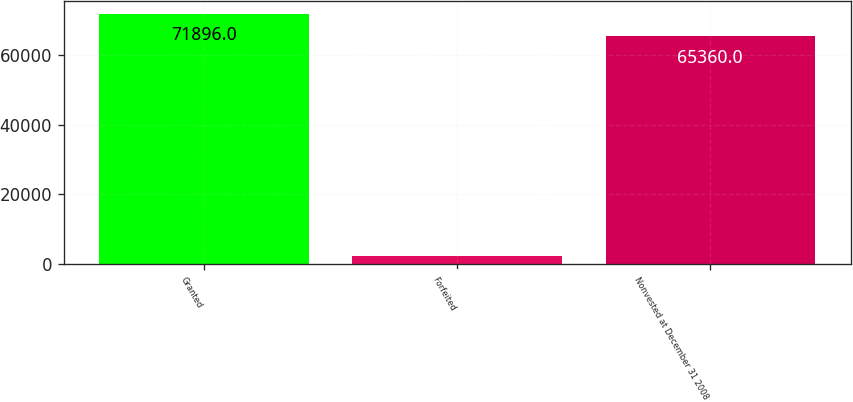Convert chart. <chart><loc_0><loc_0><loc_500><loc_500><bar_chart><fcel>Granted<fcel>Forfeited<fcel>Nonvested at December 31 2008<nl><fcel>71896<fcel>2370<fcel>65360<nl></chart> 